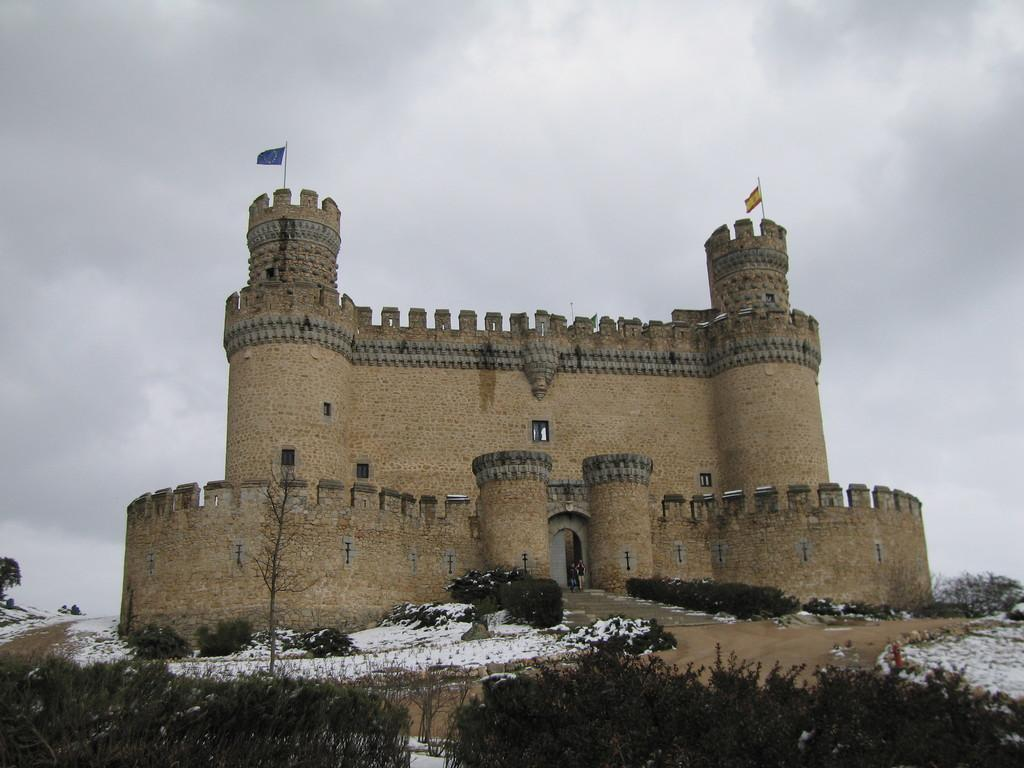What type of structure is located on the hill in the image? There is a castle on a hill in the image. How many flags are visible on the castle? The castle has two flags. What can be seen at the bottom of the hill? There are trees and snow at the bottom of the hill. What is visible in the background of the image? The sky is visible in the background of the image. What is the condition of the sky in the image? There are clouds in the sky in the image. What type of glue is being used to hold the castle together in the image? There is no glue present in the image; the castle is a solid structure. Can you see a hole in the castle wall in the image? There is no hole visible in the castle wall in the image. 